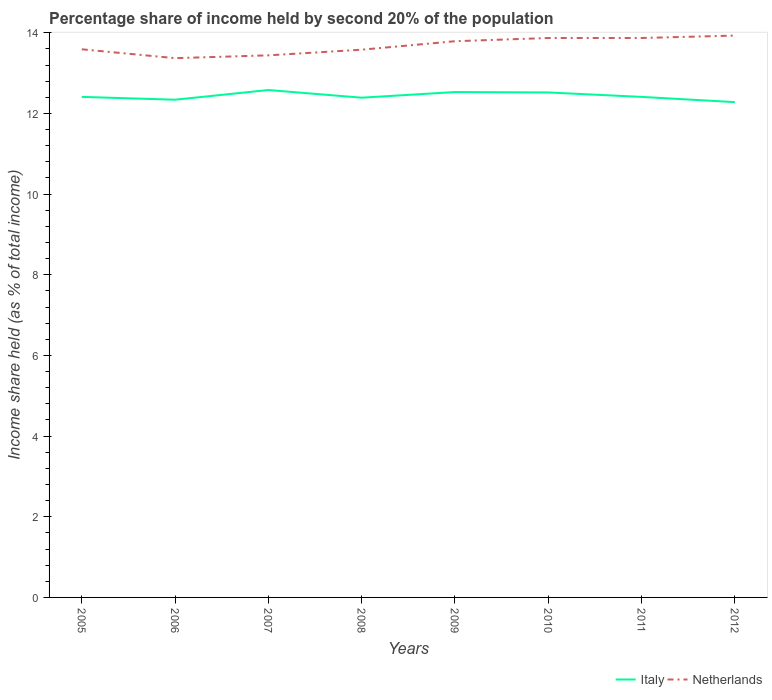Does the line corresponding to Italy intersect with the line corresponding to Netherlands?
Your answer should be very brief. No. Across all years, what is the maximum share of income held by second 20% of the population in Italy?
Your answer should be very brief. 12.28. What is the total share of income held by second 20% of the population in Netherlands in the graph?
Give a very brief answer. -0.14. What is the difference between the highest and the second highest share of income held by second 20% of the population in Italy?
Your response must be concise. 0.3. Is the share of income held by second 20% of the population in Netherlands strictly greater than the share of income held by second 20% of the population in Italy over the years?
Your response must be concise. No. How many lines are there?
Offer a very short reply. 2. Are the values on the major ticks of Y-axis written in scientific E-notation?
Offer a terse response. No. Does the graph contain grids?
Make the answer very short. No. How many legend labels are there?
Offer a terse response. 2. How are the legend labels stacked?
Offer a very short reply. Horizontal. What is the title of the graph?
Provide a succinct answer. Percentage share of income held by second 20% of the population. Does "Peru" appear as one of the legend labels in the graph?
Provide a succinct answer. No. What is the label or title of the Y-axis?
Offer a terse response. Income share held (as % of total income). What is the Income share held (as % of total income) in Italy in 2005?
Ensure brevity in your answer.  12.41. What is the Income share held (as % of total income) of Netherlands in 2005?
Your answer should be very brief. 13.59. What is the Income share held (as % of total income) in Italy in 2006?
Your answer should be compact. 12.34. What is the Income share held (as % of total income) in Netherlands in 2006?
Keep it short and to the point. 13.37. What is the Income share held (as % of total income) in Italy in 2007?
Your response must be concise. 12.58. What is the Income share held (as % of total income) of Netherlands in 2007?
Make the answer very short. 13.44. What is the Income share held (as % of total income) in Italy in 2008?
Provide a short and direct response. 12.39. What is the Income share held (as % of total income) of Netherlands in 2008?
Offer a terse response. 13.58. What is the Income share held (as % of total income) of Italy in 2009?
Make the answer very short. 12.53. What is the Income share held (as % of total income) of Netherlands in 2009?
Your answer should be very brief. 13.79. What is the Income share held (as % of total income) in Italy in 2010?
Give a very brief answer. 12.52. What is the Income share held (as % of total income) in Netherlands in 2010?
Your answer should be very brief. 13.87. What is the Income share held (as % of total income) in Italy in 2011?
Your response must be concise. 12.41. What is the Income share held (as % of total income) of Netherlands in 2011?
Offer a very short reply. 13.87. What is the Income share held (as % of total income) of Italy in 2012?
Your answer should be compact. 12.28. What is the Income share held (as % of total income) of Netherlands in 2012?
Your answer should be very brief. 13.93. Across all years, what is the maximum Income share held (as % of total income) in Italy?
Your answer should be very brief. 12.58. Across all years, what is the maximum Income share held (as % of total income) in Netherlands?
Offer a very short reply. 13.93. Across all years, what is the minimum Income share held (as % of total income) of Italy?
Give a very brief answer. 12.28. Across all years, what is the minimum Income share held (as % of total income) of Netherlands?
Ensure brevity in your answer.  13.37. What is the total Income share held (as % of total income) of Italy in the graph?
Your answer should be compact. 99.46. What is the total Income share held (as % of total income) in Netherlands in the graph?
Make the answer very short. 109.44. What is the difference between the Income share held (as % of total income) in Italy in 2005 and that in 2006?
Offer a very short reply. 0.07. What is the difference between the Income share held (as % of total income) of Netherlands in 2005 and that in 2006?
Provide a short and direct response. 0.22. What is the difference between the Income share held (as % of total income) of Italy in 2005 and that in 2007?
Offer a very short reply. -0.17. What is the difference between the Income share held (as % of total income) of Netherlands in 2005 and that in 2007?
Your response must be concise. 0.15. What is the difference between the Income share held (as % of total income) in Italy in 2005 and that in 2008?
Your response must be concise. 0.02. What is the difference between the Income share held (as % of total income) in Netherlands in 2005 and that in 2008?
Provide a short and direct response. 0.01. What is the difference between the Income share held (as % of total income) of Italy in 2005 and that in 2009?
Your response must be concise. -0.12. What is the difference between the Income share held (as % of total income) in Netherlands in 2005 and that in 2009?
Ensure brevity in your answer.  -0.2. What is the difference between the Income share held (as % of total income) in Italy in 2005 and that in 2010?
Keep it short and to the point. -0.11. What is the difference between the Income share held (as % of total income) of Netherlands in 2005 and that in 2010?
Provide a succinct answer. -0.28. What is the difference between the Income share held (as % of total income) of Netherlands in 2005 and that in 2011?
Your answer should be compact. -0.28. What is the difference between the Income share held (as % of total income) of Italy in 2005 and that in 2012?
Your answer should be very brief. 0.13. What is the difference between the Income share held (as % of total income) of Netherlands in 2005 and that in 2012?
Your response must be concise. -0.34. What is the difference between the Income share held (as % of total income) in Italy in 2006 and that in 2007?
Offer a terse response. -0.24. What is the difference between the Income share held (as % of total income) of Netherlands in 2006 and that in 2007?
Give a very brief answer. -0.07. What is the difference between the Income share held (as % of total income) in Italy in 2006 and that in 2008?
Provide a short and direct response. -0.05. What is the difference between the Income share held (as % of total income) of Netherlands in 2006 and that in 2008?
Provide a short and direct response. -0.21. What is the difference between the Income share held (as % of total income) in Italy in 2006 and that in 2009?
Your answer should be compact. -0.19. What is the difference between the Income share held (as % of total income) of Netherlands in 2006 and that in 2009?
Your response must be concise. -0.42. What is the difference between the Income share held (as % of total income) in Italy in 2006 and that in 2010?
Give a very brief answer. -0.18. What is the difference between the Income share held (as % of total income) in Italy in 2006 and that in 2011?
Provide a succinct answer. -0.07. What is the difference between the Income share held (as % of total income) of Netherlands in 2006 and that in 2011?
Your answer should be very brief. -0.5. What is the difference between the Income share held (as % of total income) of Italy in 2006 and that in 2012?
Your answer should be compact. 0.06. What is the difference between the Income share held (as % of total income) of Netherlands in 2006 and that in 2012?
Your answer should be compact. -0.56. What is the difference between the Income share held (as % of total income) of Italy in 2007 and that in 2008?
Give a very brief answer. 0.19. What is the difference between the Income share held (as % of total income) of Netherlands in 2007 and that in 2008?
Provide a short and direct response. -0.14. What is the difference between the Income share held (as % of total income) of Netherlands in 2007 and that in 2009?
Give a very brief answer. -0.35. What is the difference between the Income share held (as % of total income) in Netherlands in 2007 and that in 2010?
Your response must be concise. -0.43. What is the difference between the Income share held (as % of total income) of Italy in 2007 and that in 2011?
Keep it short and to the point. 0.17. What is the difference between the Income share held (as % of total income) of Netherlands in 2007 and that in 2011?
Provide a short and direct response. -0.43. What is the difference between the Income share held (as % of total income) in Italy in 2007 and that in 2012?
Your answer should be compact. 0.3. What is the difference between the Income share held (as % of total income) in Netherlands in 2007 and that in 2012?
Your response must be concise. -0.49. What is the difference between the Income share held (as % of total income) in Italy in 2008 and that in 2009?
Your answer should be compact. -0.14. What is the difference between the Income share held (as % of total income) of Netherlands in 2008 and that in 2009?
Provide a succinct answer. -0.21. What is the difference between the Income share held (as % of total income) in Italy in 2008 and that in 2010?
Provide a succinct answer. -0.13. What is the difference between the Income share held (as % of total income) in Netherlands in 2008 and that in 2010?
Provide a short and direct response. -0.29. What is the difference between the Income share held (as % of total income) in Italy in 2008 and that in 2011?
Ensure brevity in your answer.  -0.02. What is the difference between the Income share held (as % of total income) in Netherlands in 2008 and that in 2011?
Provide a succinct answer. -0.29. What is the difference between the Income share held (as % of total income) of Italy in 2008 and that in 2012?
Provide a short and direct response. 0.11. What is the difference between the Income share held (as % of total income) in Netherlands in 2008 and that in 2012?
Provide a succinct answer. -0.35. What is the difference between the Income share held (as % of total income) in Netherlands in 2009 and that in 2010?
Your answer should be compact. -0.08. What is the difference between the Income share held (as % of total income) in Italy in 2009 and that in 2011?
Your answer should be very brief. 0.12. What is the difference between the Income share held (as % of total income) of Netherlands in 2009 and that in 2011?
Your answer should be very brief. -0.08. What is the difference between the Income share held (as % of total income) of Italy in 2009 and that in 2012?
Your answer should be very brief. 0.25. What is the difference between the Income share held (as % of total income) of Netherlands in 2009 and that in 2012?
Offer a very short reply. -0.14. What is the difference between the Income share held (as % of total income) of Italy in 2010 and that in 2011?
Offer a terse response. 0.11. What is the difference between the Income share held (as % of total income) in Netherlands in 2010 and that in 2011?
Give a very brief answer. 0. What is the difference between the Income share held (as % of total income) in Italy in 2010 and that in 2012?
Provide a short and direct response. 0.24. What is the difference between the Income share held (as % of total income) in Netherlands in 2010 and that in 2012?
Your answer should be very brief. -0.06. What is the difference between the Income share held (as % of total income) in Italy in 2011 and that in 2012?
Provide a short and direct response. 0.13. What is the difference between the Income share held (as % of total income) in Netherlands in 2011 and that in 2012?
Ensure brevity in your answer.  -0.06. What is the difference between the Income share held (as % of total income) in Italy in 2005 and the Income share held (as % of total income) in Netherlands in 2006?
Provide a succinct answer. -0.96. What is the difference between the Income share held (as % of total income) in Italy in 2005 and the Income share held (as % of total income) in Netherlands in 2007?
Offer a very short reply. -1.03. What is the difference between the Income share held (as % of total income) of Italy in 2005 and the Income share held (as % of total income) of Netherlands in 2008?
Make the answer very short. -1.17. What is the difference between the Income share held (as % of total income) in Italy in 2005 and the Income share held (as % of total income) in Netherlands in 2009?
Provide a short and direct response. -1.38. What is the difference between the Income share held (as % of total income) in Italy in 2005 and the Income share held (as % of total income) in Netherlands in 2010?
Ensure brevity in your answer.  -1.46. What is the difference between the Income share held (as % of total income) in Italy in 2005 and the Income share held (as % of total income) in Netherlands in 2011?
Keep it short and to the point. -1.46. What is the difference between the Income share held (as % of total income) in Italy in 2005 and the Income share held (as % of total income) in Netherlands in 2012?
Provide a succinct answer. -1.52. What is the difference between the Income share held (as % of total income) of Italy in 2006 and the Income share held (as % of total income) of Netherlands in 2007?
Your answer should be very brief. -1.1. What is the difference between the Income share held (as % of total income) in Italy in 2006 and the Income share held (as % of total income) in Netherlands in 2008?
Keep it short and to the point. -1.24. What is the difference between the Income share held (as % of total income) of Italy in 2006 and the Income share held (as % of total income) of Netherlands in 2009?
Offer a very short reply. -1.45. What is the difference between the Income share held (as % of total income) of Italy in 2006 and the Income share held (as % of total income) of Netherlands in 2010?
Provide a short and direct response. -1.53. What is the difference between the Income share held (as % of total income) of Italy in 2006 and the Income share held (as % of total income) of Netherlands in 2011?
Keep it short and to the point. -1.53. What is the difference between the Income share held (as % of total income) of Italy in 2006 and the Income share held (as % of total income) of Netherlands in 2012?
Ensure brevity in your answer.  -1.59. What is the difference between the Income share held (as % of total income) in Italy in 2007 and the Income share held (as % of total income) in Netherlands in 2008?
Offer a very short reply. -1. What is the difference between the Income share held (as % of total income) in Italy in 2007 and the Income share held (as % of total income) in Netherlands in 2009?
Ensure brevity in your answer.  -1.21. What is the difference between the Income share held (as % of total income) in Italy in 2007 and the Income share held (as % of total income) in Netherlands in 2010?
Provide a succinct answer. -1.29. What is the difference between the Income share held (as % of total income) in Italy in 2007 and the Income share held (as % of total income) in Netherlands in 2011?
Ensure brevity in your answer.  -1.29. What is the difference between the Income share held (as % of total income) in Italy in 2007 and the Income share held (as % of total income) in Netherlands in 2012?
Make the answer very short. -1.35. What is the difference between the Income share held (as % of total income) of Italy in 2008 and the Income share held (as % of total income) of Netherlands in 2010?
Offer a terse response. -1.48. What is the difference between the Income share held (as % of total income) in Italy in 2008 and the Income share held (as % of total income) in Netherlands in 2011?
Keep it short and to the point. -1.48. What is the difference between the Income share held (as % of total income) in Italy in 2008 and the Income share held (as % of total income) in Netherlands in 2012?
Make the answer very short. -1.54. What is the difference between the Income share held (as % of total income) in Italy in 2009 and the Income share held (as % of total income) in Netherlands in 2010?
Provide a succinct answer. -1.34. What is the difference between the Income share held (as % of total income) in Italy in 2009 and the Income share held (as % of total income) in Netherlands in 2011?
Offer a very short reply. -1.34. What is the difference between the Income share held (as % of total income) of Italy in 2010 and the Income share held (as % of total income) of Netherlands in 2011?
Offer a very short reply. -1.35. What is the difference between the Income share held (as % of total income) of Italy in 2010 and the Income share held (as % of total income) of Netherlands in 2012?
Ensure brevity in your answer.  -1.41. What is the difference between the Income share held (as % of total income) in Italy in 2011 and the Income share held (as % of total income) in Netherlands in 2012?
Your response must be concise. -1.52. What is the average Income share held (as % of total income) of Italy per year?
Provide a succinct answer. 12.43. What is the average Income share held (as % of total income) in Netherlands per year?
Provide a succinct answer. 13.68. In the year 2005, what is the difference between the Income share held (as % of total income) in Italy and Income share held (as % of total income) in Netherlands?
Your response must be concise. -1.18. In the year 2006, what is the difference between the Income share held (as % of total income) in Italy and Income share held (as % of total income) in Netherlands?
Your answer should be very brief. -1.03. In the year 2007, what is the difference between the Income share held (as % of total income) in Italy and Income share held (as % of total income) in Netherlands?
Your answer should be compact. -0.86. In the year 2008, what is the difference between the Income share held (as % of total income) of Italy and Income share held (as % of total income) of Netherlands?
Give a very brief answer. -1.19. In the year 2009, what is the difference between the Income share held (as % of total income) of Italy and Income share held (as % of total income) of Netherlands?
Your response must be concise. -1.26. In the year 2010, what is the difference between the Income share held (as % of total income) in Italy and Income share held (as % of total income) in Netherlands?
Make the answer very short. -1.35. In the year 2011, what is the difference between the Income share held (as % of total income) in Italy and Income share held (as % of total income) in Netherlands?
Offer a very short reply. -1.46. In the year 2012, what is the difference between the Income share held (as % of total income) in Italy and Income share held (as % of total income) in Netherlands?
Make the answer very short. -1.65. What is the ratio of the Income share held (as % of total income) in Netherlands in 2005 to that in 2006?
Offer a very short reply. 1.02. What is the ratio of the Income share held (as % of total income) in Italy in 2005 to that in 2007?
Your answer should be very brief. 0.99. What is the ratio of the Income share held (as % of total income) of Netherlands in 2005 to that in 2007?
Your answer should be very brief. 1.01. What is the ratio of the Income share held (as % of total income) of Italy in 2005 to that in 2008?
Give a very brief answer. 1. What is the ratio of the Income share held (as % of total income) of Italy in 2005 to that in 2009?
Offer a terse response. 0.99. What is the ratio of the Income share held (as % of total income) of Netherlands in 2005 to that in 2009?
Keep it short and to the point. 0.99. What is the ratio of the Income share held (as % of total income) in Netherlands in 2005 to that in 2010?
Your answer should be compact. 0.98. What is the ratio of the Income share held (as % of total income) in Netherlands in 2005 to that in 2011?
Your answer should be compact. 0.98. What is the ratio of the Income share held (as % of total income) in Italy in 2005 to that in 2012?
Your answer should be compact. 1.01. What is the ratio of the Income share held (as % of total income) of Netherlands in 2005 to that in 2012?
Give a very brief answer. 0.98. What is the ratio of the Income share held (as % of total income) in Italy in 2006 to that in 2007?
Give a very brief answer. 0.98. What is the ratio of the Income share held (as % of total income) of Netherlands in 2006 to that in 2007?
Your answer should be very brief. 0.99. What is the ratio of the Income share held (as % of total income) in Netherlands in 2006 to that in 2008?
Provide a short and direct response. 0.98. What is the ratio of the Income share held (as % of total income) in Netherlands in 2006 to that in 2009?
Offer a very short reply. 0.97. What is the ratio of the Income share held (as % of total income) of Italy in 2006 to that in 2010?
Provide a succinct answer. 0.99. What is the ratio of the Income share held (as % of total income) in Netherlands in 2006 to that in 2012?
Provide a short and direct response. 0.96. What is the ratio of the Income share held (as % of total income) of Italy in 2007 to that in 2008?
Provide a succinct answer. 1.02. What is the ratio of the Income share held (as % of total income) of Netherlands in 2007 to that in 2008?
Your response must be concise. 0.99. What is the ratio of the Income share held (as % of total income) in Netherlands in 2007 to that in 2009?
Make the answer very short. 0.97. What is the ratio of the Income share held (as % of total income) of Italy in 2007 to that in 2010?
Keep it short and to the point. 1. What is the ratio of the Income share held (as % of total income) of Netherlands in 2007 to that in 2010?
Keep it short and to the point. 0.97. What is the ratio of the Income share held (as % of total income) of Italy in 2007 to that in 2011?
Make the answer very short. 1.01. What is the ratio of the Income share held (as % of total income) in Italy in 2007 to that in 2012?
Offer a terse response. 1.02. What is the ratio of the Income share held (as % of total income) in Netherlands in 2007 to that in 2012?
Your answer should be very brief. 0.96. What is the ratio of the Income share held (as % of total income) in Italy in 2008 to that in 2009?
Offer a terse response. 0.99. What is the ratio of the Income share held (as % of total income) in Netherlands in 2008 to that in 2010?
Offer a terse response. 0.98. What is the ratio of the Income share held (as % of total income) in Netherlands in 2008 to that in 2011?
Give a very brief answer. 0.98. What is the ratio of the Income share held (as % of total income) of Italy in 2008 to that in 2012?
Offer a very short reply. 1.01. What is the ratio of the Income share held (as % of total income) in Netherlands in 2008 to that in 2012?
Offer a terse response. 0.97. What is the ratio of the Income share held (as % of total income) in Italy in 2009 to that in 2011?
Provide a succinct answer. 1.01. What is the ratio of the Income share held (as % of total income) of Italy in 2009 to that in 2012?
Offer a terse response. 1.02. What is the ratio of the Income share held (as % of total income) in Netherlands in 2009 to that in 2012?
Make the answer very short. 0.99. What is the ratio of the Income share held (as % of total income) in Italy in 2010 to that in 2011?
Make the answer very short. 1.01. What is the ratio of the Income share held (as % of total income) in Netherlands in 2010 to that in 2011?
Give a very brief answer. 1. What is the ratio of the Income share held (as % of total income) of Italy in 2010 to that in 2012?
Offer a very short reply. 1.02. What is the ratio of the Income share held (as % of total income) in Netherlands in 2010 to that in 2012?
Your response must be concise. 1. What is the ratio of the Income share held (as % of total income) of Italy in 2011 to that in 2012?
Keep it short and to the point. 1.01. What is the ratio of the Income share held (as % of total income) of Netherlands in 2011 to that in 2012?
Provide a succinct answer. 1. What is the difference between the highest and the lowest Income share held (as % of total income) in Italy?
Keep it short and to the point. 0.3. What is the difference between the highest and the lowest Income share held (as % of total income) in Netherlands?
Provide a succinct answer. 0.56. 